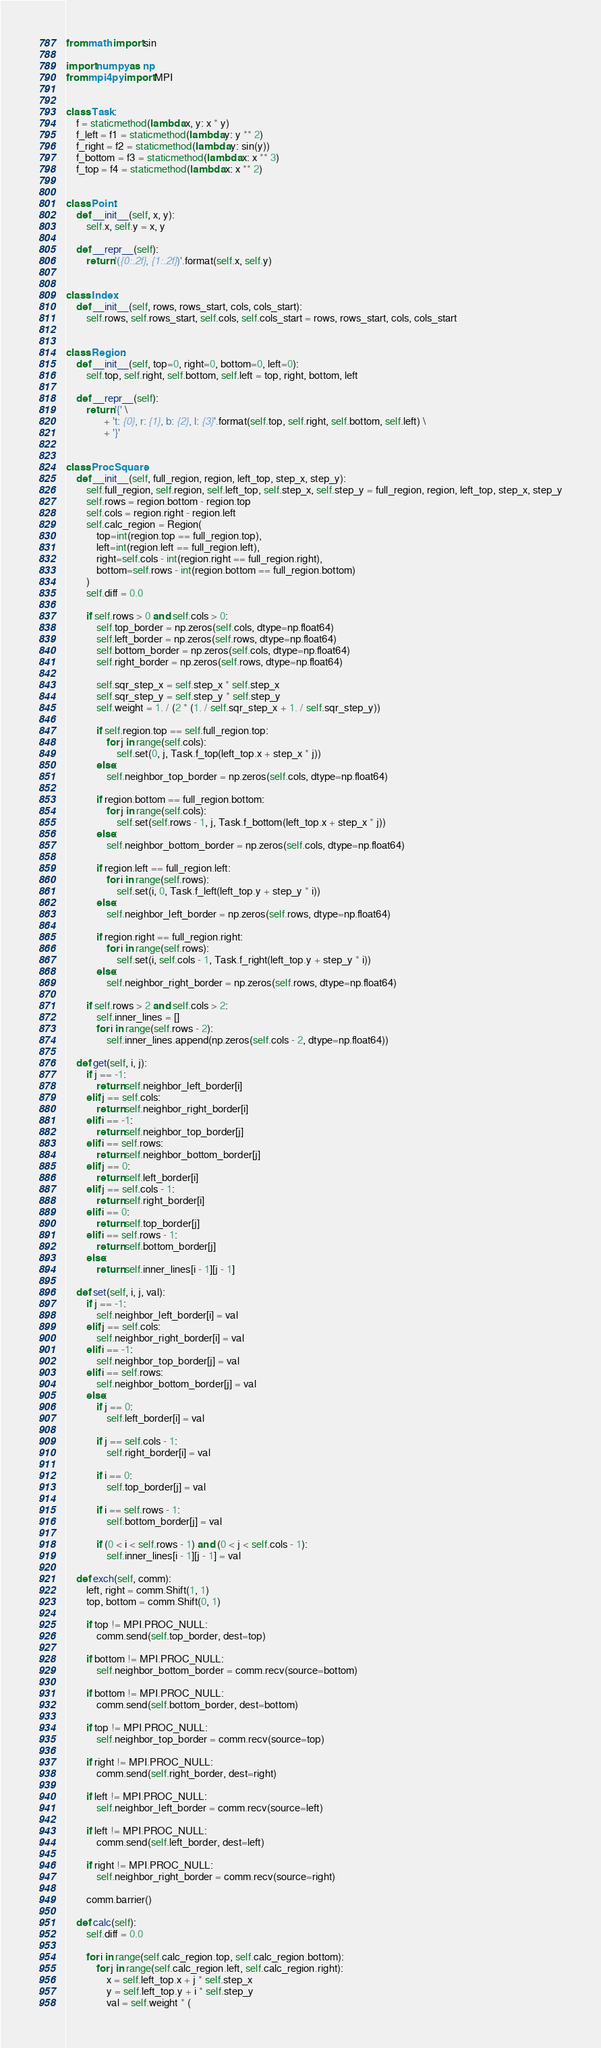Convert code to text. <code><loc_0><loc_0><loc_500><loc_500><_Python_>from math import sin

import numpy as np
from mpi4py import MPI


class Task:
    f = staticmethod(lambda x, y: x * y)
    f_left = f1 = staticmethod(lambda y: y ** 2)
    f_right = f2 = staticmethod(lambda y: sin(y))
    f_bottom = f3 = staticmethod(lambda x: x ** 3)
    f_top = f4 = staticmethod(lambda x: x ** 2)


class Point:
    def __init__(self, x, y):
        self.x, self.y = x, y

    def __repr__(self):
        return '({0:.2f}, {1:.2f})'.format(self.x, self.y)


class Index:
    def __init__(self, rows, rows_start, cols, cols_start):
        self.rows, self.rows_start, self.cols, self.cols_start = rows, rows_start, cols, cols_start


class Region:
    def __init__(self, top=0, right=0, bottom=0, left=0):
        self.top, self.right, self.bottom, self.left = top, right, bottom, left

    def __repr__(self):
        return '{' \
               + 't: {0}, r: {1}, b: {2}, l: {3}'.format(self.top, self.right, self.bottom, self.left) \
               + '}'


class ProcSquare:
    def __init__(self, full_region, region, left_top, step_x, step_y):
        self.full_region, self.region, self.left_top, self.step_x, self.step_y = full_region, region, left_top, step_x, step_y
        self.rows = region.bottom - region.top
        self.cols = region.right - region.left
        self.calc_region = Region(
            top=int(region.top == full_region.top),
            left=int(region.left == full_region.left),
            right=self.cols - int(region.right == full_region.right),
            bottom=self.rows - int(region.bottom == full_region.bottom)
        )
        self.diff = 0.0

        if self.rows > 0 and self.cols > 0:
            self.top_border = np.zeros(self.cols, dtype=np.float64)
            self.left_border = np.zeros(self.rows, dtype=np.float64)
            self.bottom_border = np.zeros(self.cols, dtype=np.float64)
            self.right_border = np.zeros(self.rows, dtype=np.float64)

            self.sqr_step_x = self.step_x * self.step_x
            self.sqr_step_y = self.step_y * self.step_y
            self.weight = 1. / (2 * (1. / self.sqr_step_x + 1. / self.sqr_step_y))

            if self.region.top == self.full_region.top:
                for j in range(self.cols):
                    self.set(0, j, Task.f_top(left_top.x + step_x * j))
            else:
                self.neighbor_top_border = np.zeros(self.cols, dtype=np.float64)

            if region.bottom == full_region.bottom:
                for j in range(self.cols):
                    self.set(self.rows - 1, j, Task.f_bottom(left_top.x + step_x * j))
            else:
                self.neighbor_bottom_border = np.zeros(self.cols, dtype=np.float64)

            if region.left == full_region.left:
                for i in range(self.rows):
                    self.set(i, 0, Task.f_left(left_top.y + step_y * i))
            else:
                self.neighbor_left_border = np.zeros(self.rows, dtype=np.float64)

            if region.right == full_region.right:
                for i in range(self.rows):
                    self.set(i, self.cols - 1, Task.f_right(left_top.y + step_y * i))
            else:
                self.neighbor_right_border = np.zeros(self.rows, dtype=np.float64)

        if self.rows > 2 and self.cols > 2:
            self.inner_lines = []
            for i in range(self.rows - 2):
                self.inner_lines.append(np.zeros(self.cols - 2, dtype=np.float64))

    def get(self, i, j):
        if j == -1:
            return self.neighbor_left_border[i]
        elif j == self.cols:
            return self.neighbor_right_border[i]
        elif i == -1:
            return self.neighbor_top_border[j]
        elif i == self.rows:
            return self.neighbor_bottom_border[j]
        elif j == 0:
            return self.left_border[i]
        elif j == self.cols - 1:
            return self.right_border[i]
        elif i == 0:
            return self.top_border[j]
        elif i == self.rows - 1:
            return self.bottom_border[j]
        else:
            return self.inner_lines[i - 1][j - 1]

    def set(self, i, j, val):
        if j == -1:
            self.neighbor_left_border[i] = val
        elif j == self.cols:
            self.neighbor_right_border[i] = val
        elif i == -1:
            self.neighbor_top_border[j] = val
        elif i == self.rows:
            self.neighbor_bottom_border[j] = val
        else:
            if j == 0:
                self.left_border[i] = val

            if j == self.cols - 1:
                self.right_border[i] = val

            if i == 0:
                self.top_border[j] = val

            if i == self.rows - 1:
                self.bottom_border[j] = val

            if (0 < i < self.rows - 1) and (0 < j < self.cols - 1):
                self.inner_lines[i - 1][j - 1] = val

    def exch(self, comm):
        left, right = comm.Shift(1, 1)
        top, bottom = comm.Shift(0, 1)

        if top != MPI.PROC_NULL:
            comm.send(self.top_border, dest=top)

        if bottom != MPI.PROC_NULL:
            self.neighbor_bottom_border = comm.recv(source=bottom)

        if bottom != MPI.PROC_NULL:
            comm.send(self.bottom_border, dest=bottom)

        if top != MPI.PROC_NULL:
            self.neighbor_top_border = comm.recv(source=top)

        if right != MPI.PROC_NULL:
            comm.send(self.right_border, dest=right)

        if left != MPI.PROC_NULL:
            self.neighbor_left_border = comm.recv(source=left)

        if left != MPI.PROC_NULL:
            comm.send(self.left_border, dest=left)

        if right != MPI.PROC_NULL:
            self.neighbor_right_border = comm.recv(source=right)

        comm.barrier()

    def calc(self):
        self.diff = 0.0

        for i in range(self.calc_region.top, self.calc_region.bottom):
            for j in range(self.calc_region.left, self.calc_region.right):
                x = self.left_top.x + j * self.step_x
                y = self.left_top.y + i * self.step_y
                val = self.weight * (</code> 